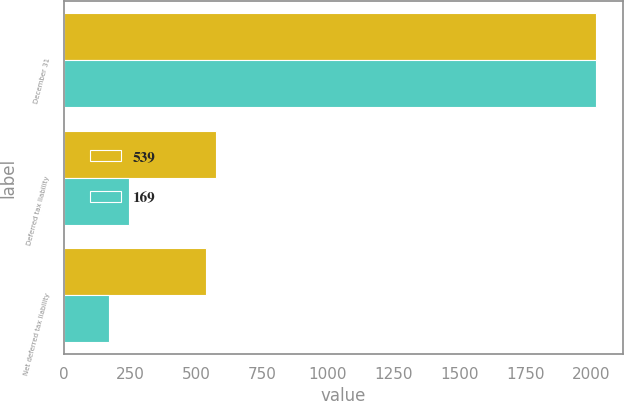Convert chart to OTSL. <chart><loc_0><loc_0><loc_500><loc_500><stacked_bar_chart><ecel><fcel>December 31<fcel>Deferred tax liability<fcel>Net deferred tax liability<nl><fcel>539<fcel>2018<fcel>577<fcel>539<nl><fcel>169<fcel>2017<fcel>244<fcel>169<nl></chart> 